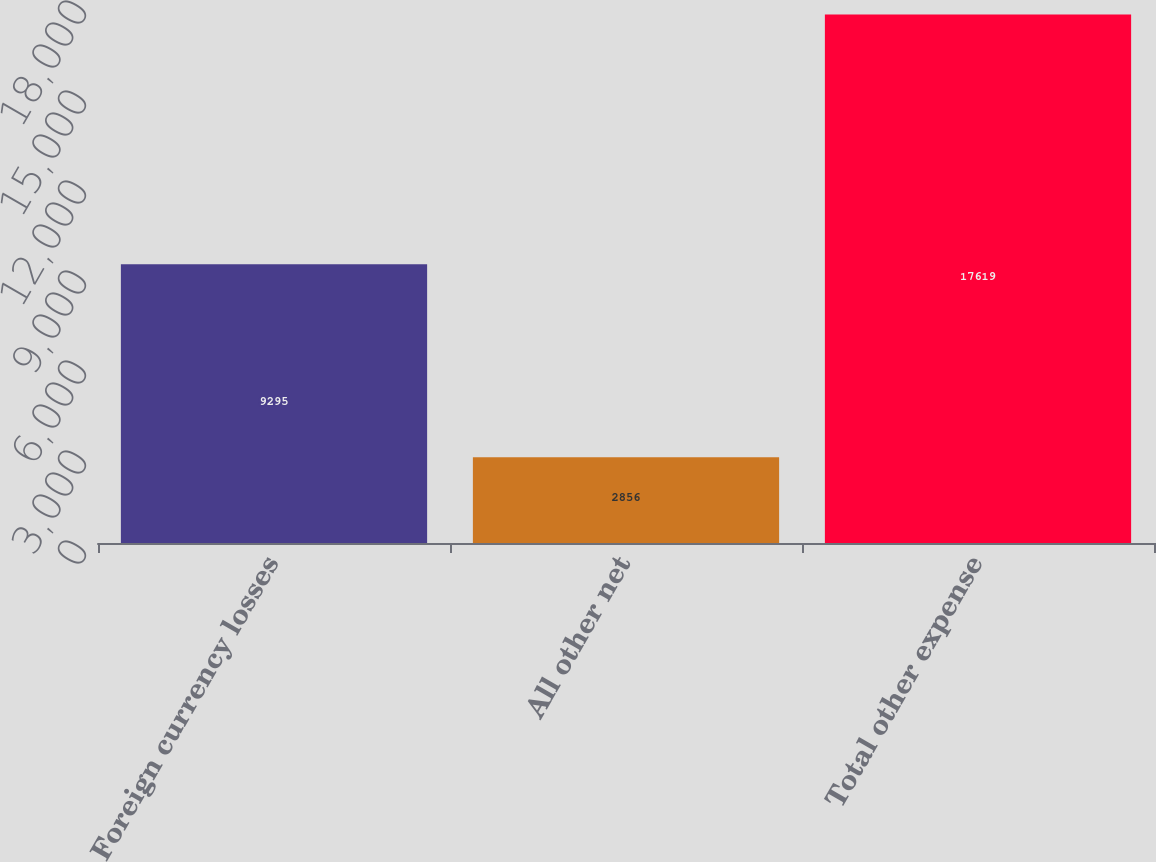Convert chart to OTSL. <chart><loc_0><loc_0><loc_500><loc_500><bar_chart><fcel>Foreign currency losses<fcel>All other net<fcel>Total other expense<nl><fcel>9295<fcel>2856<fcel>17619<nl></chart> 